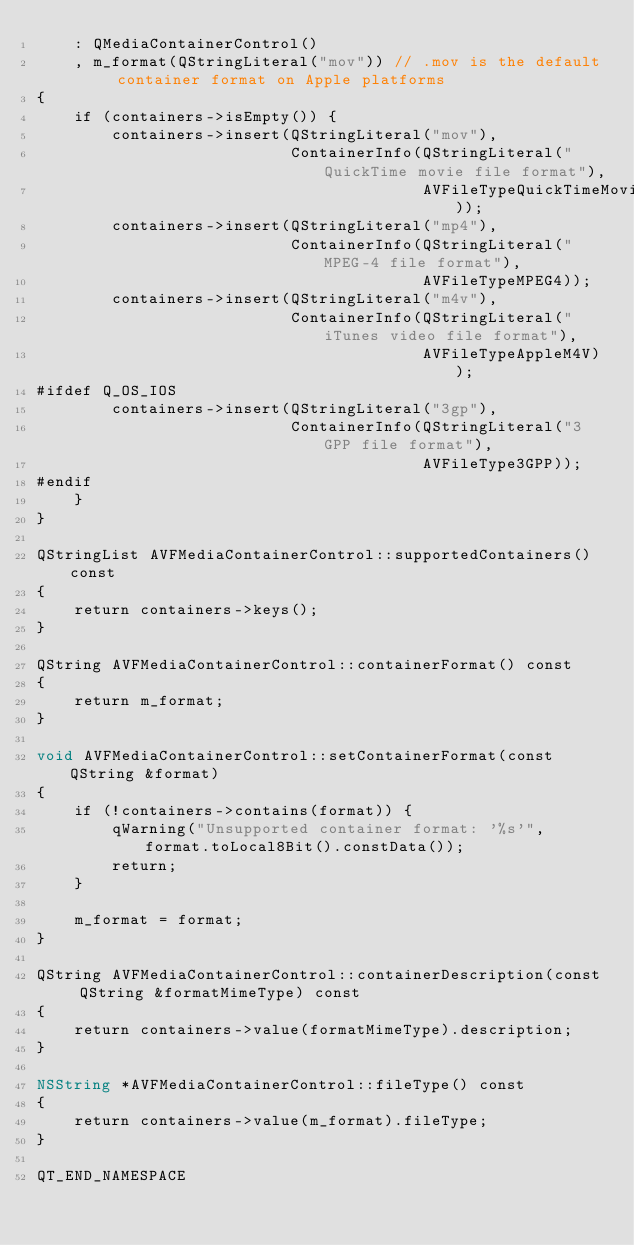Convert code to text. <code><loc_0><loc_0><loc_500><loc_500><_ObjectiveC_>    : QMediaContainerControl()
    , m_format(QStringLiteral("mov")) // .mov is the default container format on Apple platforms
{
    if (containers->isEmpty()) {
        containers->insert(QStringLiteral("mov"),
                           ContainerInfo(QStringLiteral("QuickTime movie file format"),
                                         AVFileTypeQuickTimeMovie));
        containers->insert(QStringLiteral("mp4"),
                           ContainerInfo(QStringLiteral("MPEG-4 file format"),
                                         AVFileTypeMPEG4));
        containers->insert(QStringLiteral("m4v"),
                           ContainerInfo(QStringLiteral("iTunes video file format"),
                                         AVFileTypeAppleM4V));
#ifdef Q_OS_IOS
        containers->insert(QStringLiteral("3gp"),
                           ContainerInfo(QStringLiteral("3GPP file format"),
                                         AVFileType3GPP));
#endif
    }
}

QStringList AVFMediaContainerControl::supportedContainers() const
{
    return containers->keys();
}

QString AVFMediaContainerControl::containerFormat() const
{
    return m_format;
}

void AVFMediaContainerControl::setContainerFormat(const QString &format)
{
    if (!containers->contains(format)) {
        qWarning("Unsupported container format: '%s'", format.toLocal8Bit().constData());
        return;
    }

    m_format = format;
}

QString AVFMediaContainerControl::containerDescription(const QString &formatMimeType) const
{
    return containers->value(formatMimeType).description;
}

NSString *AVFMediaContainerControl::fileType() const
{
    return containers->value(m_format).fileType;
}

QT_END_NAMESPACE
</code> 